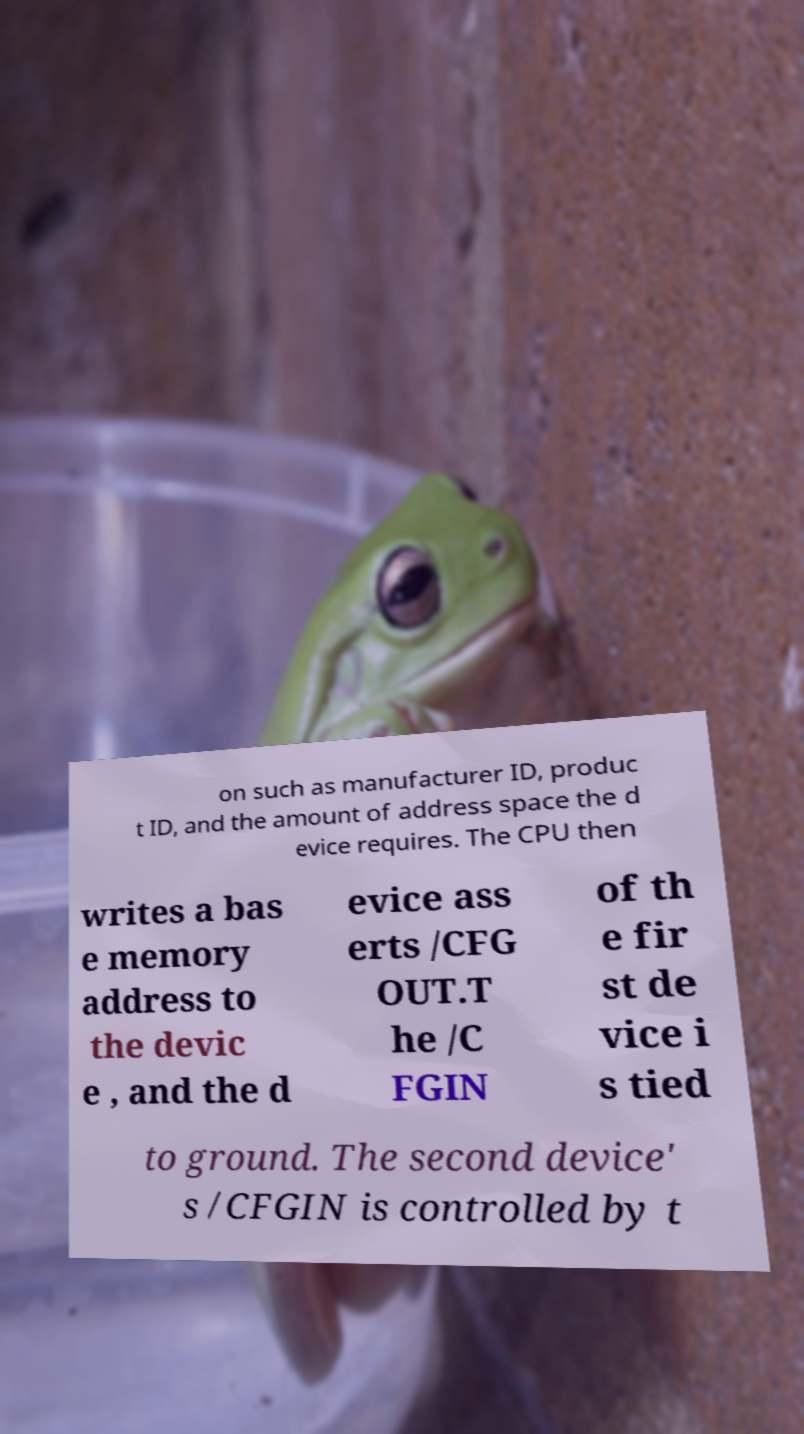Please read and relay the text visible in this image. What does it say? on such as manufacturer ID, produc t ID, and the amount of address space the d evice requires. The CPU then writes a bas e memory address to the devic e , and the d evice ass erts /CFG OUT.T he /C FGIN of th e fir st de vice i s tied to ground. The second device' s /CFGIN is controlled by t 